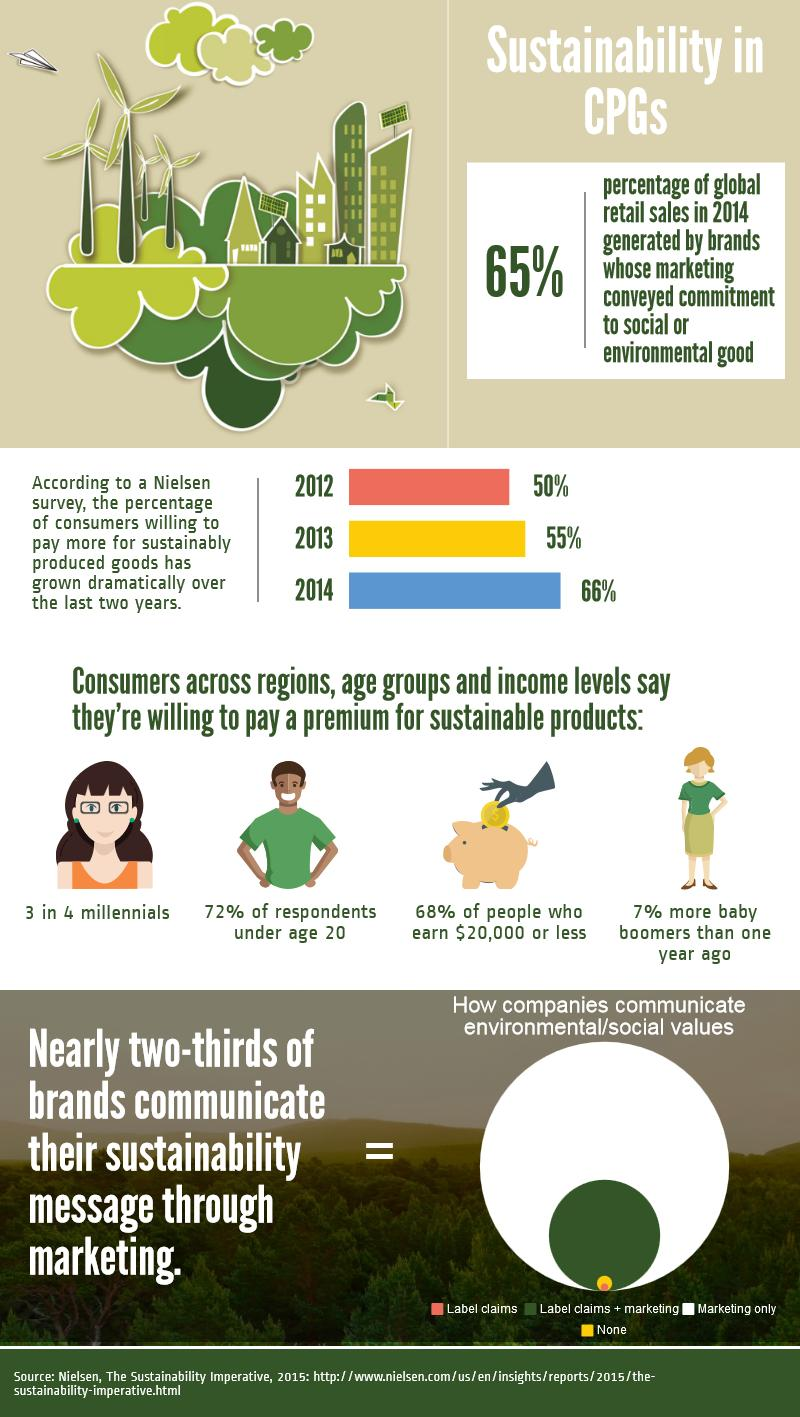Indicate a few pertinent items in this graphic. In 2012 and 2013, a significant percentage of consumers were willing to pay more for sustainably produced goods, with a combined total of 105%. A total of 121% of consumers were willing to pay more for sustainably produced goods in both the year 2014 and 2013, taken together. According to the survey, 28% of respondents are not under the age of 20. 